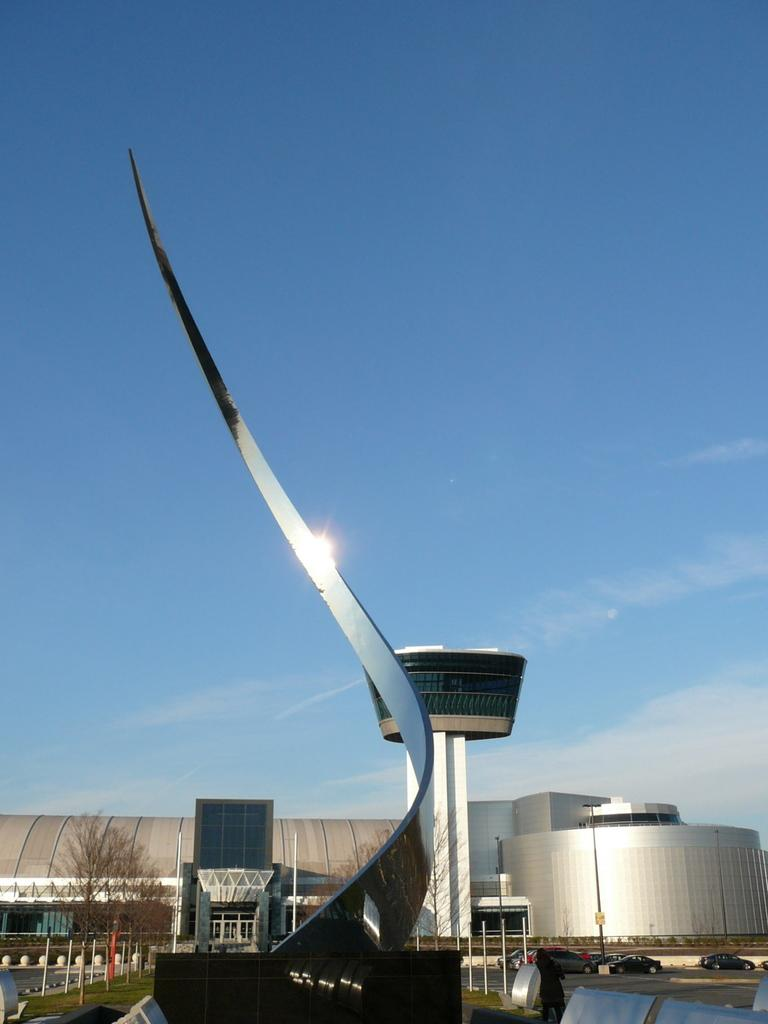What type of structures can be seen in the image? There are buildings in the image. What other elements are present in the image besides the buildings? There are plants in the image. What type of chain can be seen connecting the buildings in the image? There is no chain connecting the buildings in the image; the buildings are separate structures. 